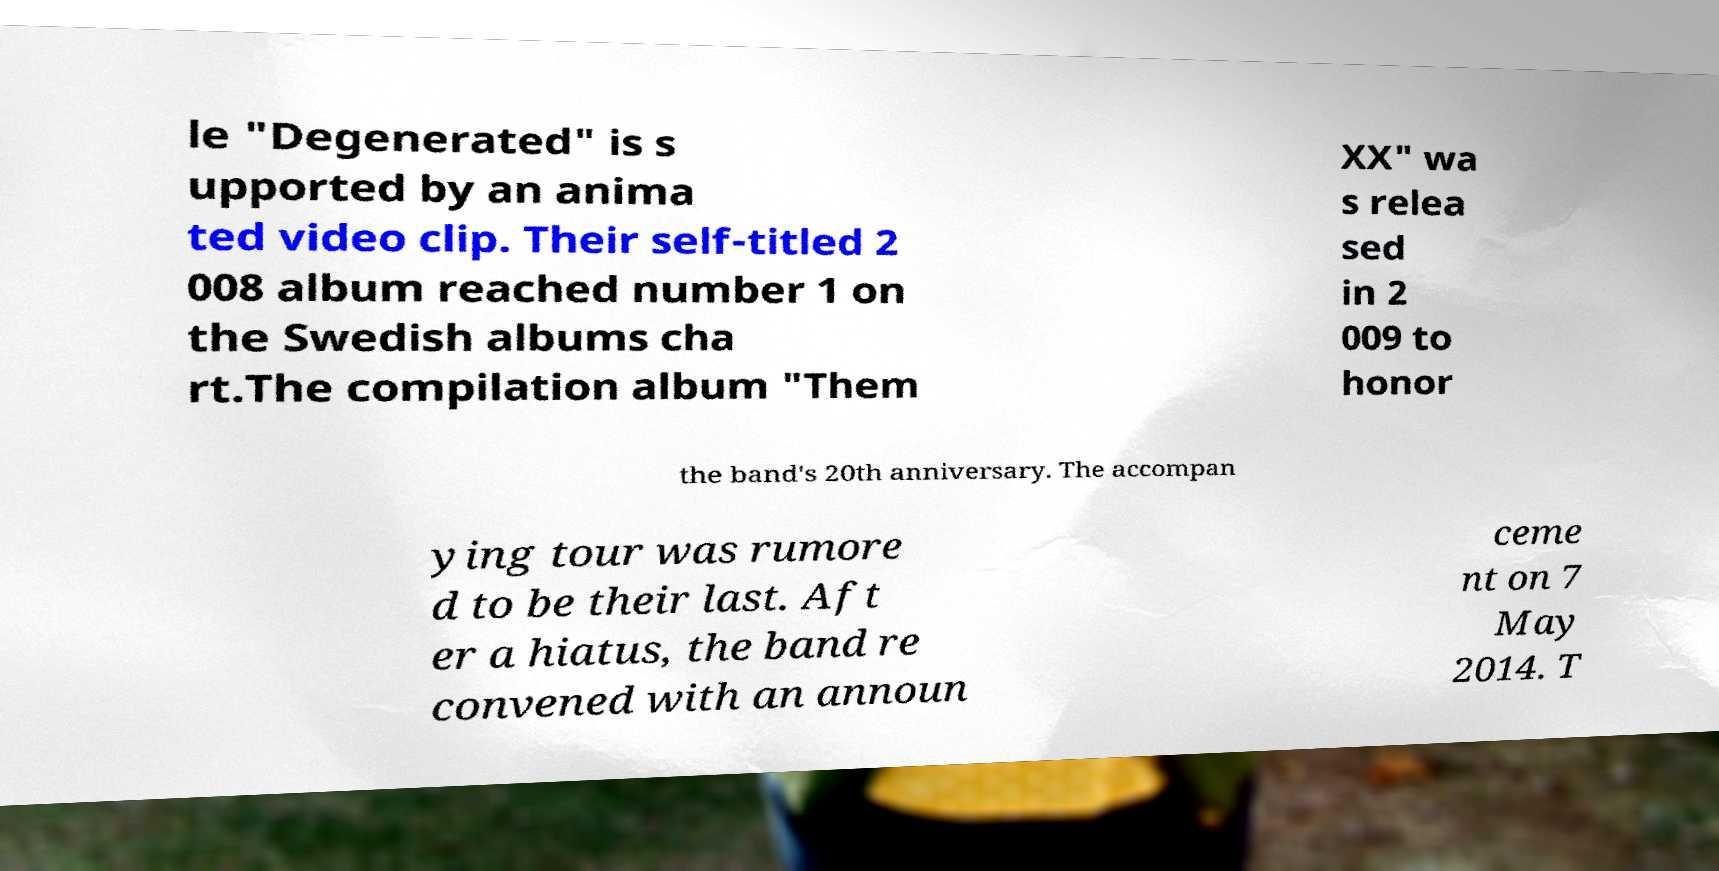Could you extract and type out the text from this image? le "Degenerated" is s upported by an anima ted video clip. Their self-titled 2 008 album reached number 1 on the Swedish albums cha rt.The compilation album "Them XX" wa s relea sed in 2 009 to honor the band's 20th anniversary. The accompan ying tour was rumore d to be their last. Aft er a hiatus, the band re convened with an announ ceme nt on 7 May 2014. T 